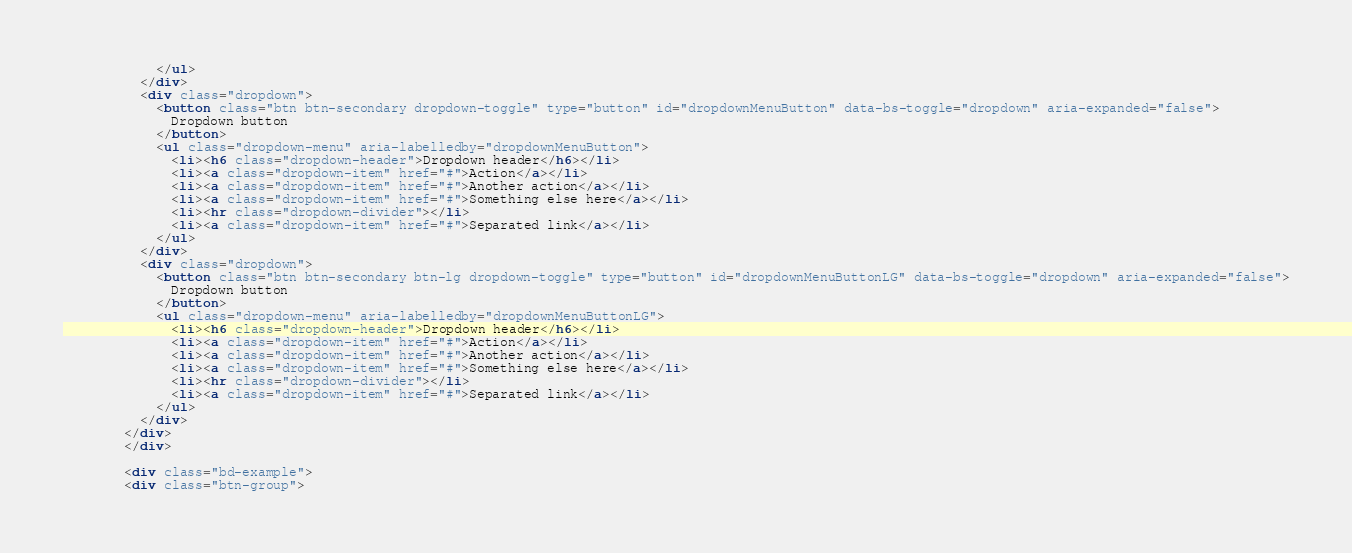Convert code to text. <code><loc_0><loc_0><loc_500><loc_500><_HTML_>            </ul>
          </div>
          <div class="dropdown">
            <button class="btn btn-secondary dropdown-toggle" type="button" id="dropdownMenuButton" data-bs-toggle="dropdown" aria-expanded="false">
              Dropdown button
            </button>
            <ul class="dropdown-menu" aria-labelledby="dropdownMenuButton">
              <li><h6 class="dropdown-header">Dropdown header</h6></li>
              <li><a class="dropdown-item" href="#">Action</a></li>
              <li><a class="dropdown-item" href="#">Another action</a></li>
              <li><a class="dropdown-item" href="#">Something else here</a></li>
              <li><hr class="dropdown-divider"></li>
              <li><a class="dropdown-item" href="#">Separated link</a></li>
            </ul>
          </div>
          <div class="dropdown">
            <button class="btn btn-secondary btn-lg dropdown-toggle" type="button" id="dropdownMenuButtonLG" data-bs-toggle="dropdown" aria-expanded="false">
              Dropdown button
            </button>
            <ul class="dropdown-menu" aria-labelledby="dropdownMenuButtonLG">
              <li><h6 class="dropdown-header">Dropdown header</h6></li>
              <li><a class="dropdown-item" href="#">Action</a></li>
              <li><a class="dropdown-item" href="#">Another action</a></li>
              <li><a class="dropdown-item" href="#">Something else here</a></li>
              <li><hr class="dropdown-divider"></li>
              <li><a class="dropdown-item" href="#">Separated link</a></li>
            </ul>
          </div>
        </div>
        </div>

        <div class="bd-example">
        <div class="btn-group"></code> 